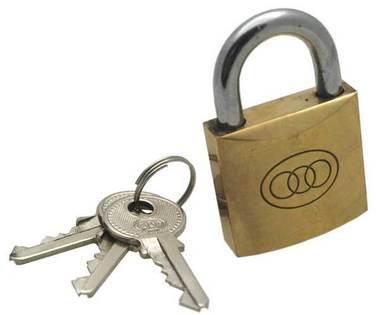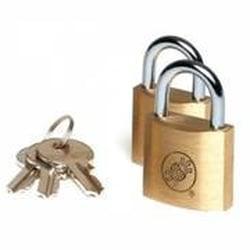The first image is the image on the left, the second image is the image on the right. Examine the images to the left and right. Is the description "There are exactly six keys." accurate? Answer yes or no. Yes. The first image is the image on the left, the second image is the image on the right. Considering the images on both sides, is "Each image contains exactly three keys and only gold-bodied locks." valid? Answer yes or no. Yes. 